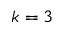<formula> <loc_0><loc_0><loc_500><loc_500>k = 3</formula> 